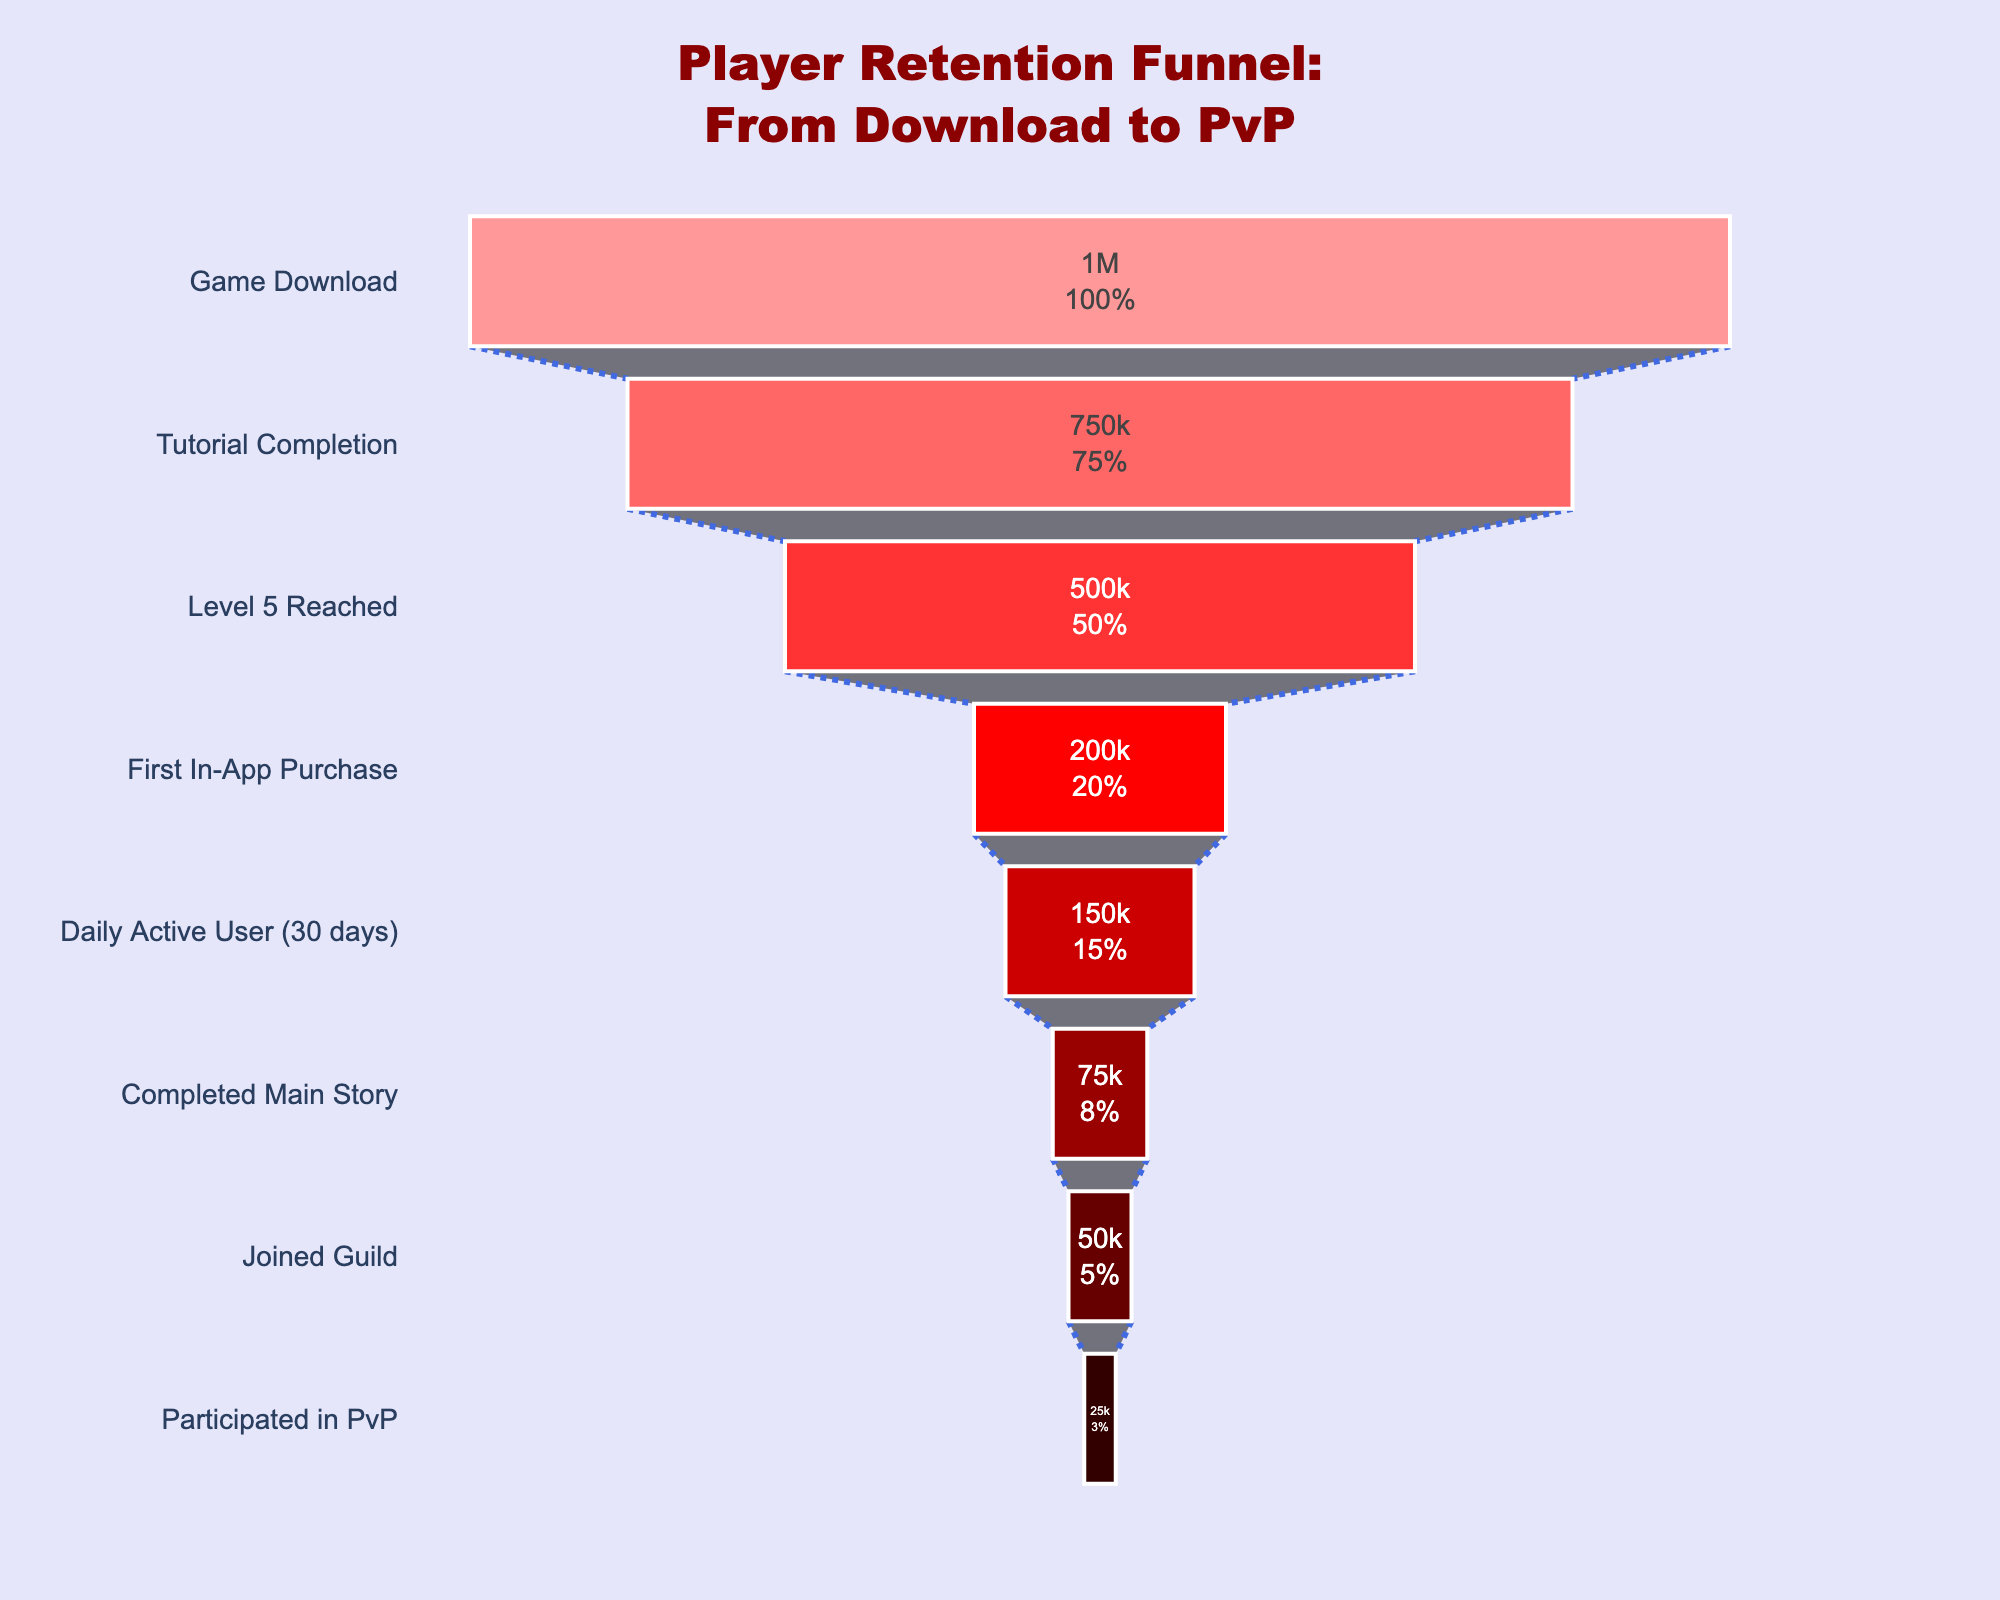What stage has the most players according to the funnel chart? The first stage, 'Game Download,' shows that it has the highest number of players compared to all other stages.
Answer: Game Download How many players completed the main story stage? From the funnel chart, we can see the number of players at each stage. The 'Completed Main Story' stage has 75,000 players.
Answer: 75,000 What percentage of players who completed the tutorial reached Level 5? The number of players who completed the tutorial is 750,000, and the number who reached Level 5 is 500,000. So, the percentage is (500,000 / 750,000) * 100%.
Answer: 66.67% Which stage has a smaller number of players: First In-App Purchase or Joined Guild? Comparing the two stages, 'First In-App Purchase' has 200,000 players, while 'Joined Guild' has 50,000 players. Therefore, 'Joined Guild' has fewer players.
Answer: Joined Guild How many players joined a guild out of those who completed the main story? The number of players who completed the main story is 75,000, and the number who joined a guild is 50,000. So, 50,000 out of 75,000 players joined a guild.
Answer: 50,000 What is the percentage decrease in players from the 'Daily Active User (30 days)' stage to the 'Participated in PvP' stage? The number of players at the 'Daily Active User (30 days)' stage is 150,000, and at the 'Participated in PvP' stage, it is 25,000. The decrease is 150,000 - 25,000 = 125,000. The percentage decrease is (125,000 / 150,000) * 100%.
Answer: 83.33% What annotation is included in the funnel chart, and what does it highlight? The chart includes an annotation that reads, "Gossip Alert: Only 2.5% reach PvP stage!". This highlights the small percentage of players who reach the PvP stage.
Answer: Only 2.5% reach PvP stage What is the number of players who made it to the level of 'First In-App Purchase'? The funnel chart shows that the number of players who reached the 'First In-App Purchase' stage is 200,000.
Answer: 200,000 How many total stages are depicted in the player retention funnel chart? By counting the stages listed on the funnel chart, there are a total of 8 stages.
Answer: 8 stages 